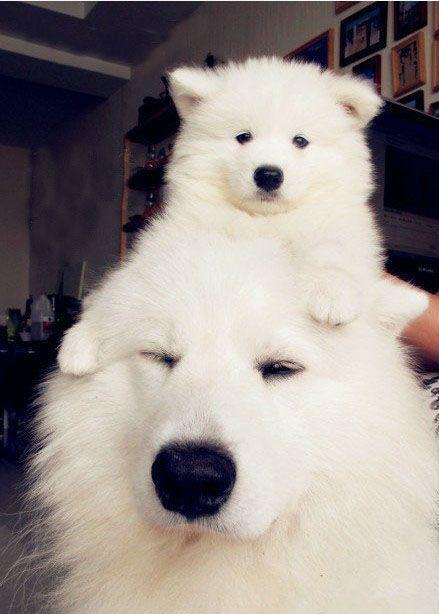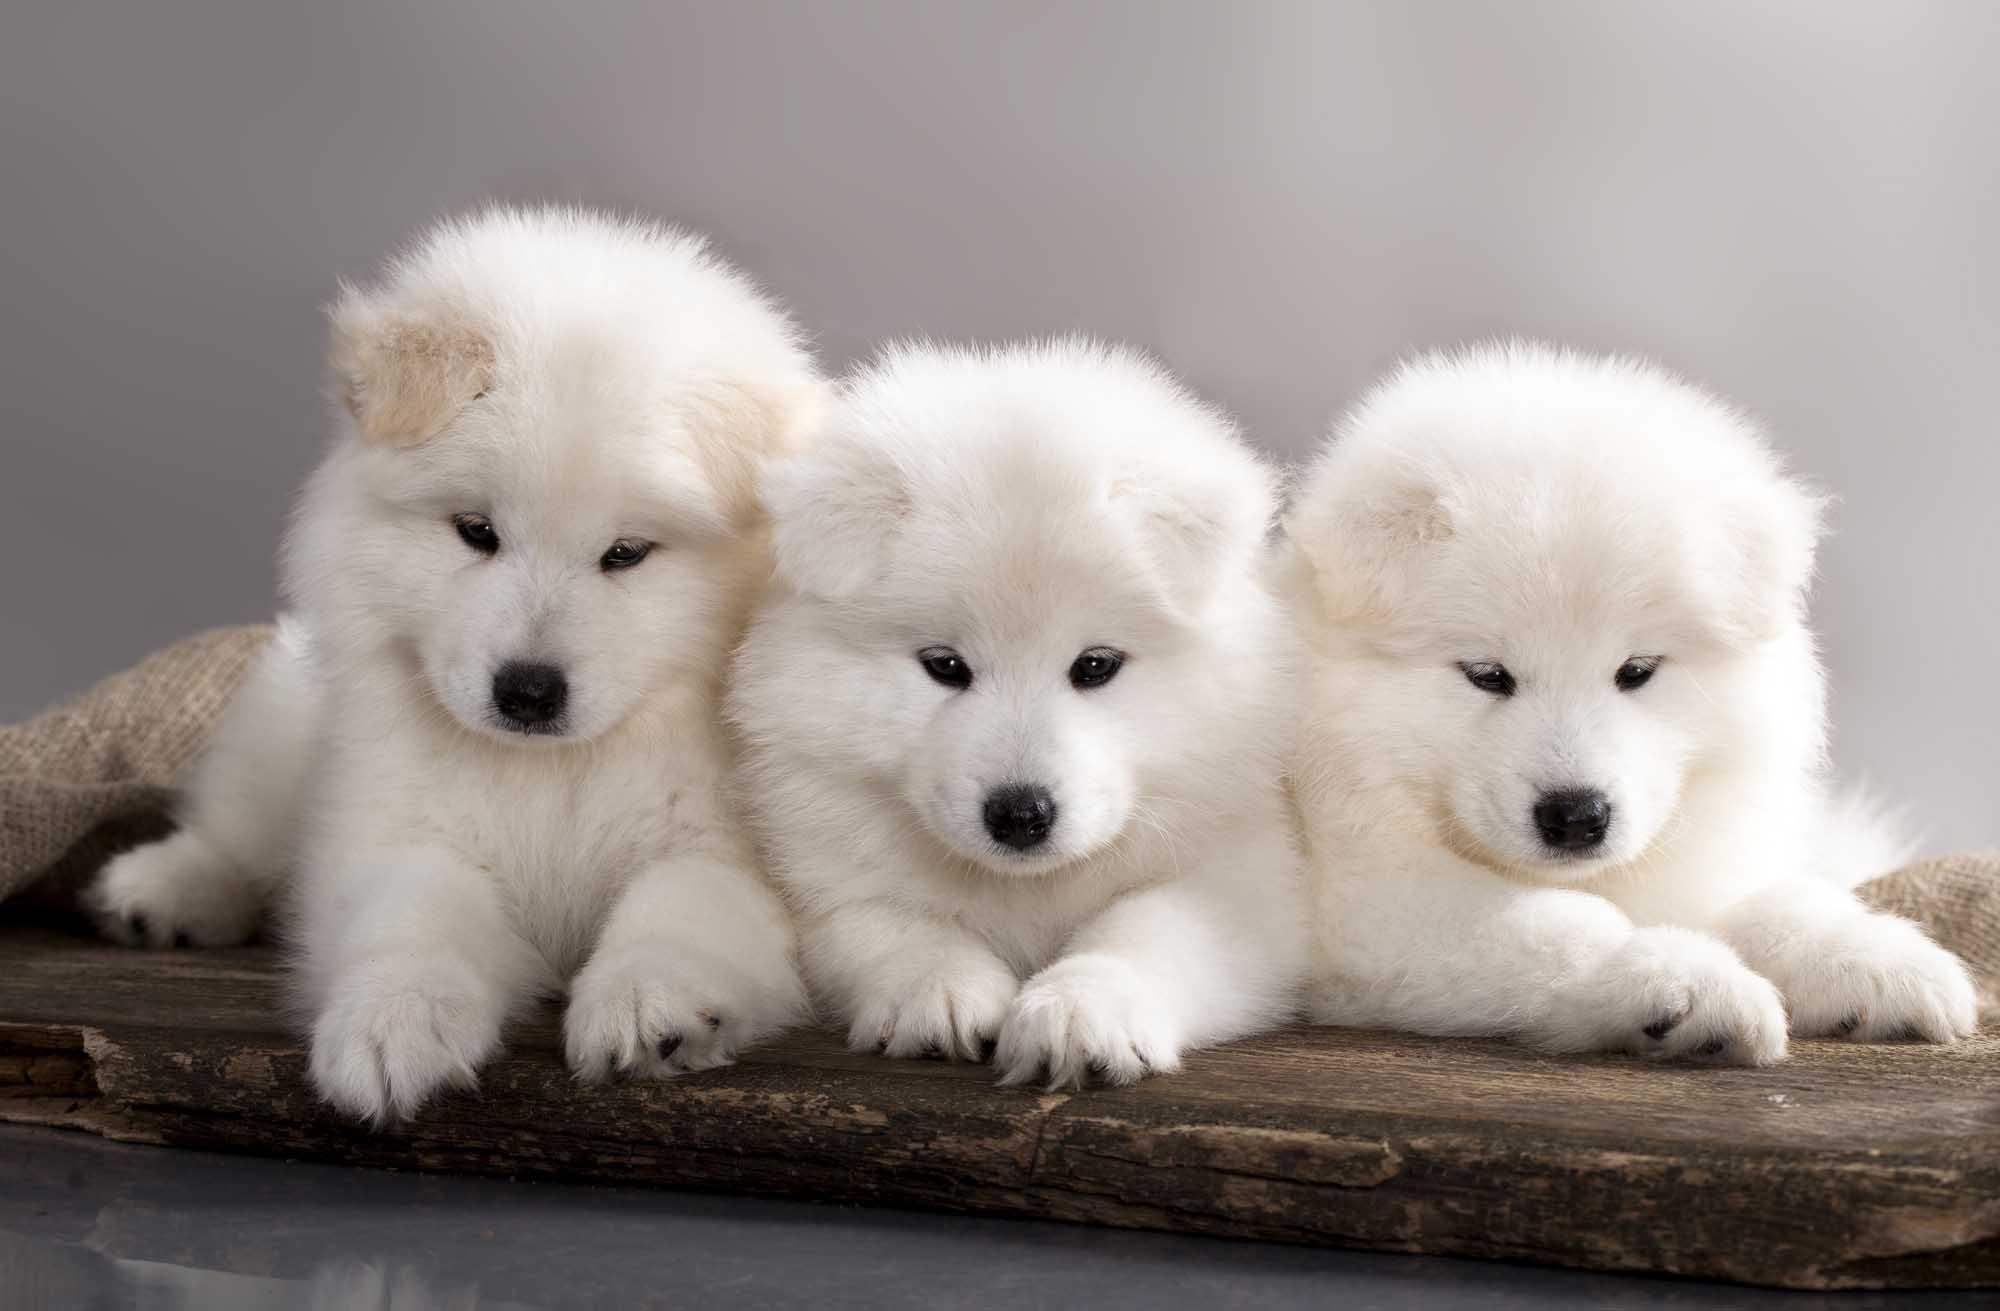The first image is the image on the left, the second image is the image on the right. Examine the images to the left and right. Is the description "At least one image has an adult dog in it." accurate? Answer yes or no. Yes. 